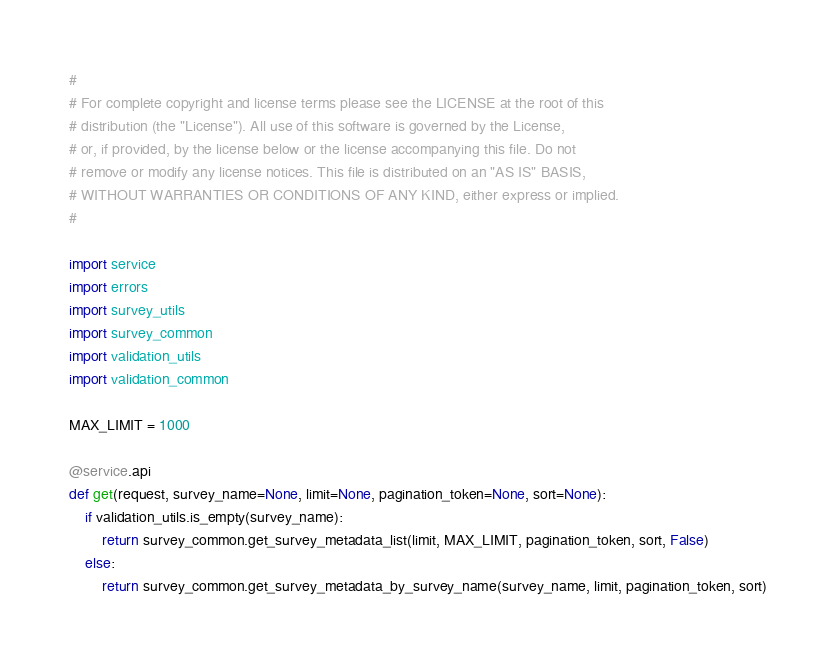Convert code to text. <code><loc_0><loc_0><loc_500><loc_500><_Python_>#
# For complete copyright and license terms please see the LICENSE at the root of this
# distribution (the "License"). All use of this software is governed by the License,
# or, if provided, by the license below or the license accompanying this file. Do not
# remove or modify any license notices. This file is distributed on an "AS IS" BASIS,
# WITHOUT WARRANTIES OR CONDITIONS OF ANY KIND, either express or implied.
#

import service
import errors
import survey_utils
import survey_common
import validation_utils
import validation_common

MAX_LIMIT = 1000

@service.api
def get(request, survey_name=None, limit=None, pagination_token=None, sort=None):
    if validation_utils.is_empty(survey_name):
        return survey_common.get_survey_metadata_list(limit, MAX_LIMIT, pagination_token, sort, False)
    else:
        return survey_common.get_survey_metadata_by_survey_name(survey_name, limit, pagination_token, sort)
</code> 